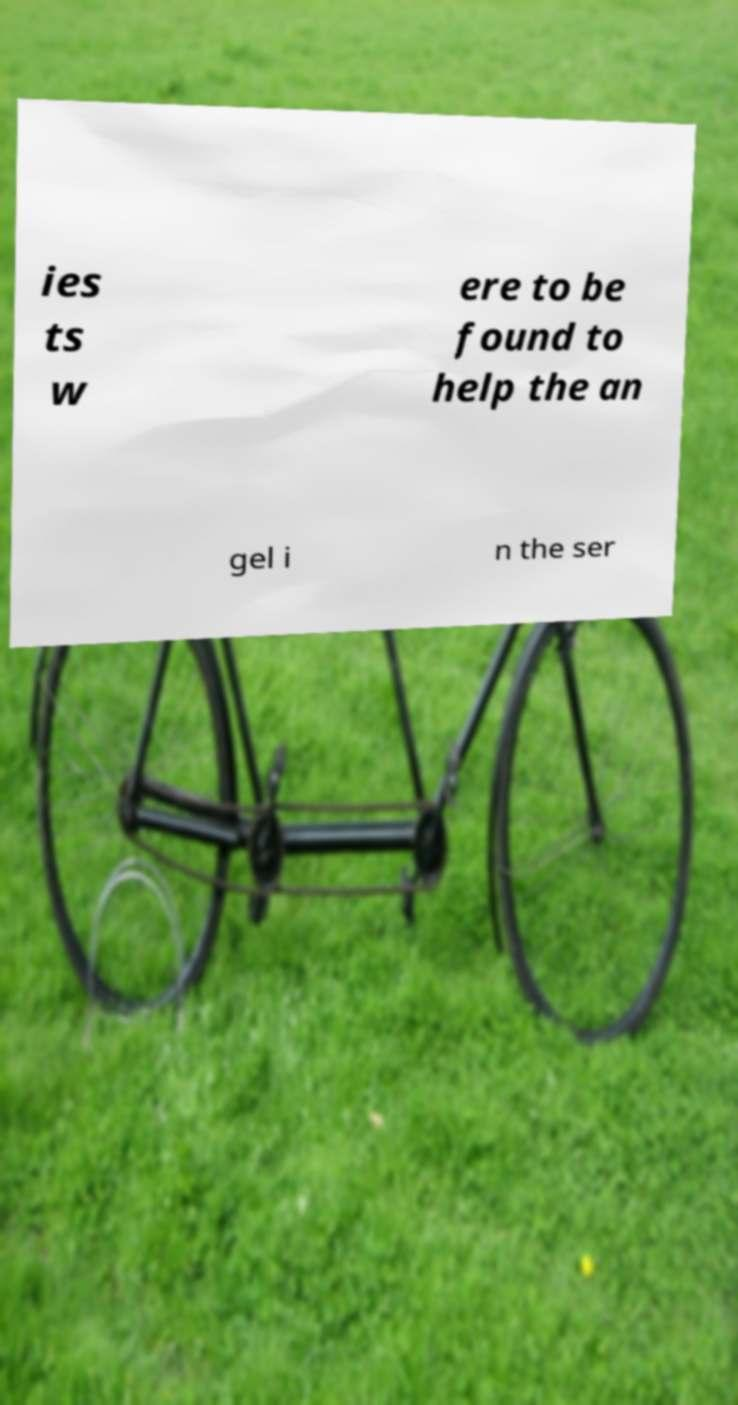Could you assist in decoding the text presented in this image and type it out clearly? ies ts w ere to be found to help the an gel i n the ser 